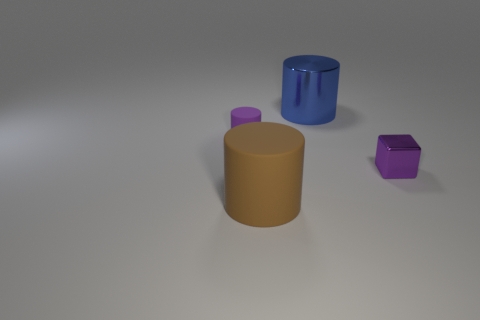There is a purple thing that is made of the same material as the big blue object; what is its size?
Ensure brevity in your answer.  Small. There is a purple matte thing that is the same shape as the blue metal thing; what is its size?
Ensure brevity in your answer.  Small. Is there anything else that is made of the same material as the blue cylinder?
Keep it short and to the point. Yes. How many objects are either large cylinders behind the small purple rubber object or cylinders in front of the purple matte cylinder?
Keep it short and to the point. 2. Do the purple block and the purple cylinder behind the brown rubber cylinder have the same material?
Ensure brevity in your answer.  No. What shape is the object that is both right of the large brown cylinder and in front of the big shiny cylinder?
Provide a succinct answer. Cube. What number of other things are the same color as the large matte object?
Make the answer very short. 0. What shape is the large metallic thing?
Ensure brevity in your answer.  Cylinder. What is the color of the matte object in front of the small purple object that is to the right of the big blue cylinder?
Offer a terse response. Brown. Does the large matte cylinder have the same color as the metallic thing that is right of the big blue metallic cylinder?
Your response must be concise. No. 